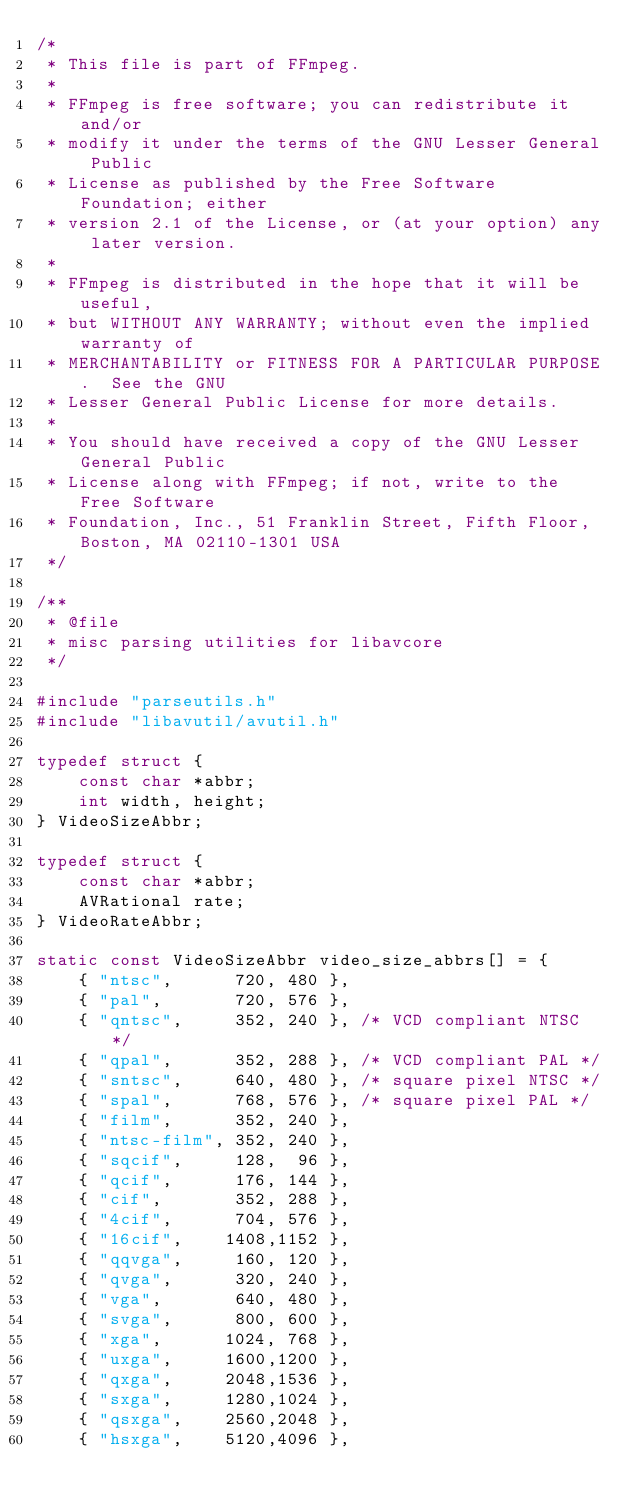Convert code to text. <code><loc_0><loc_0><loc_500><loc_500><_C_>/*
 * This file is part of FFmpeg.
 *
 * FFmpeg is free software; you can redistribute it and/or
 * modify it under the terms of the GNU Lesser General Public
 * License as published by the Free Software Foundation; either
 * version 2.1 of the License, or (at your option) any later version.
 *
 * FFmpeg is distributed in the hope that it will be useful,
 * but WITHOUT ANY WARRANTY; without even the implied warranty of
 * MERCHANTABILITY or FITNESS FOR A PARTICULAR PURPOSE.  See the GNU
 * Lesser General Public License for more details.
 *
 * You should have received a copy of the GNU Lesser General Public
 * License along with FFmpeg; if not, write to the Free Software
 * Foundation, Inc., 51 Franklin Street, Fifth Floor, Boston, MA 02110-1301 USA
 */

/**
 * @file
 * misc parsing utilities for libavcore
 */

#include "parseutils.h"
#include "libavutil/avutil.h"

typedef struct {
    const char *abbr;
    int width, height;
} VideoSizeAbbr;

typedef struct {
    const char *abbr;
    AVRational rate;
} VideoRateAbbr;

static const VideoSizeAbbr video_size_abbrs[] = {
    { "ntsc",      720, 480 },
    { "pal",       720, 576 },
    { "qntsc",     352, 240 }, /* VCD compliant NTSC */
    { "qpal",      352, 288 }, /* VCD compliant PAL */
    { "sntsc",     640, 480 }, /* square pixel NTSC */
    { "spal",      768, 576 }, /* square pixel PAL */
    { "film",      352, 240 },
    { "ntsc-film", 352, 240 },
    { "sqcif",     128,  96 },
    { "qcif",      176, 144 },
    { "cif",       352, 288 },
    { "4cif",      704, 576 },
    { "16cif",    1408,1152 },
    { "qqvga",     160, 120 },
    { "qvga",      320, 240 },
    { "vga",       640, 480 },
    { "svga",      800, 600 },
    { "xga",      1024, 768 },
    { "uxga",     1600,1200 },
    { "qxga",     2048,1536 },
    { "sxga",     1280,1024 },
    { "qsxga",    2560,2048 },
    { "hsxga",    5120,4096 },</code> 